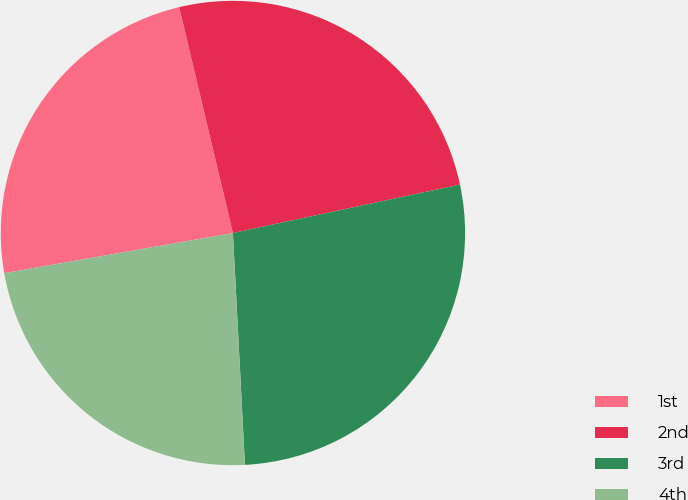<chart> <loc_0><loc_0><loc_500><loc_500><pie_chart><fcel>1st<fcel>2nd<fcel>3rd<fcel>4th<nl><fcel>24.05%<fcel>25.37%<fcel>27.52%<fcel>23.06%<nl></chart> 